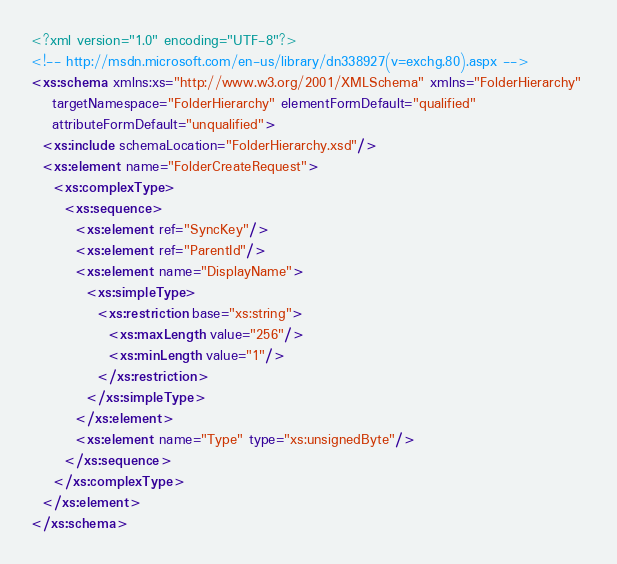Convert code to text. <code><loc_0><loc_0><loc_500><loc_500><_XML_><?xml version="1.0" encoding="UTF-8"?>
<!-- http://msdn.microsoft.com/en-us/library/dn338927(v=exchg.80).aspx -->
<xs:schema xmlns:xs="http://www.w3.org/2001/XMLSchema" xmlns="FolderHierarchy" 
    targetNamespace="FolderHierarchy" elementFormDefault="qualified" 
    attributeFormDefault="unqualified">
  <xs:include schemaLocation="FolderHierarchy.xsd"/>
  <xs:element name="FolderCreateRequest">
    <xs:complexType>
      <xs:sequence>
        <xs:element ref="SyncKey"/>
        <xs:element ref="ParentId"/>
        <xs:element name="DisplayName">
          <xs:simpleType>
            <xs:restriction base="xs:string">
              <xs:maxLength value="256"/>
              <xs:minLength value="1"/>
            </xs:restriction>
          </xs:simpleType>
        </xs:element>
        <xs:element name="Type" type="xs:unsignedByte"/>
      </xs:sequence>
    </xs:complexType>
  </xs:element>
</xs:schema>
</code> 